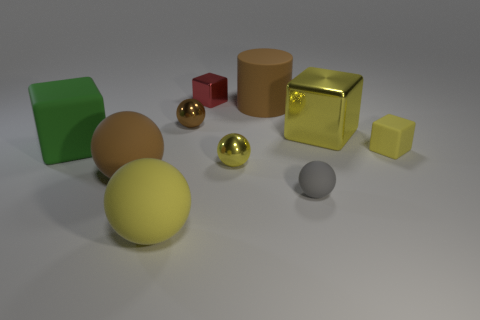How many yellow balls must be subtracted to get 1 yellow balls? 1 Subtract all cyan balls. Subtract all cyan cylinders. How many balls are left? 5 Subtract all cylinders. How many objects are left? 9 Subtract all green blocks. Subtract all tiny yellow metallic things. How many objects are left? 8 Add 6 red blocks. How many red blocks are left? 7 Add 8 large blue matte balls. How many large blue matte balls exist? 8 Subtract 0 cyan cylinders. How many objects are left? 10 